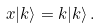<formula> <loc_0><loc_0><loc_500><loc_500>x | k \rangle = k | k \rangle \, .</formula> 